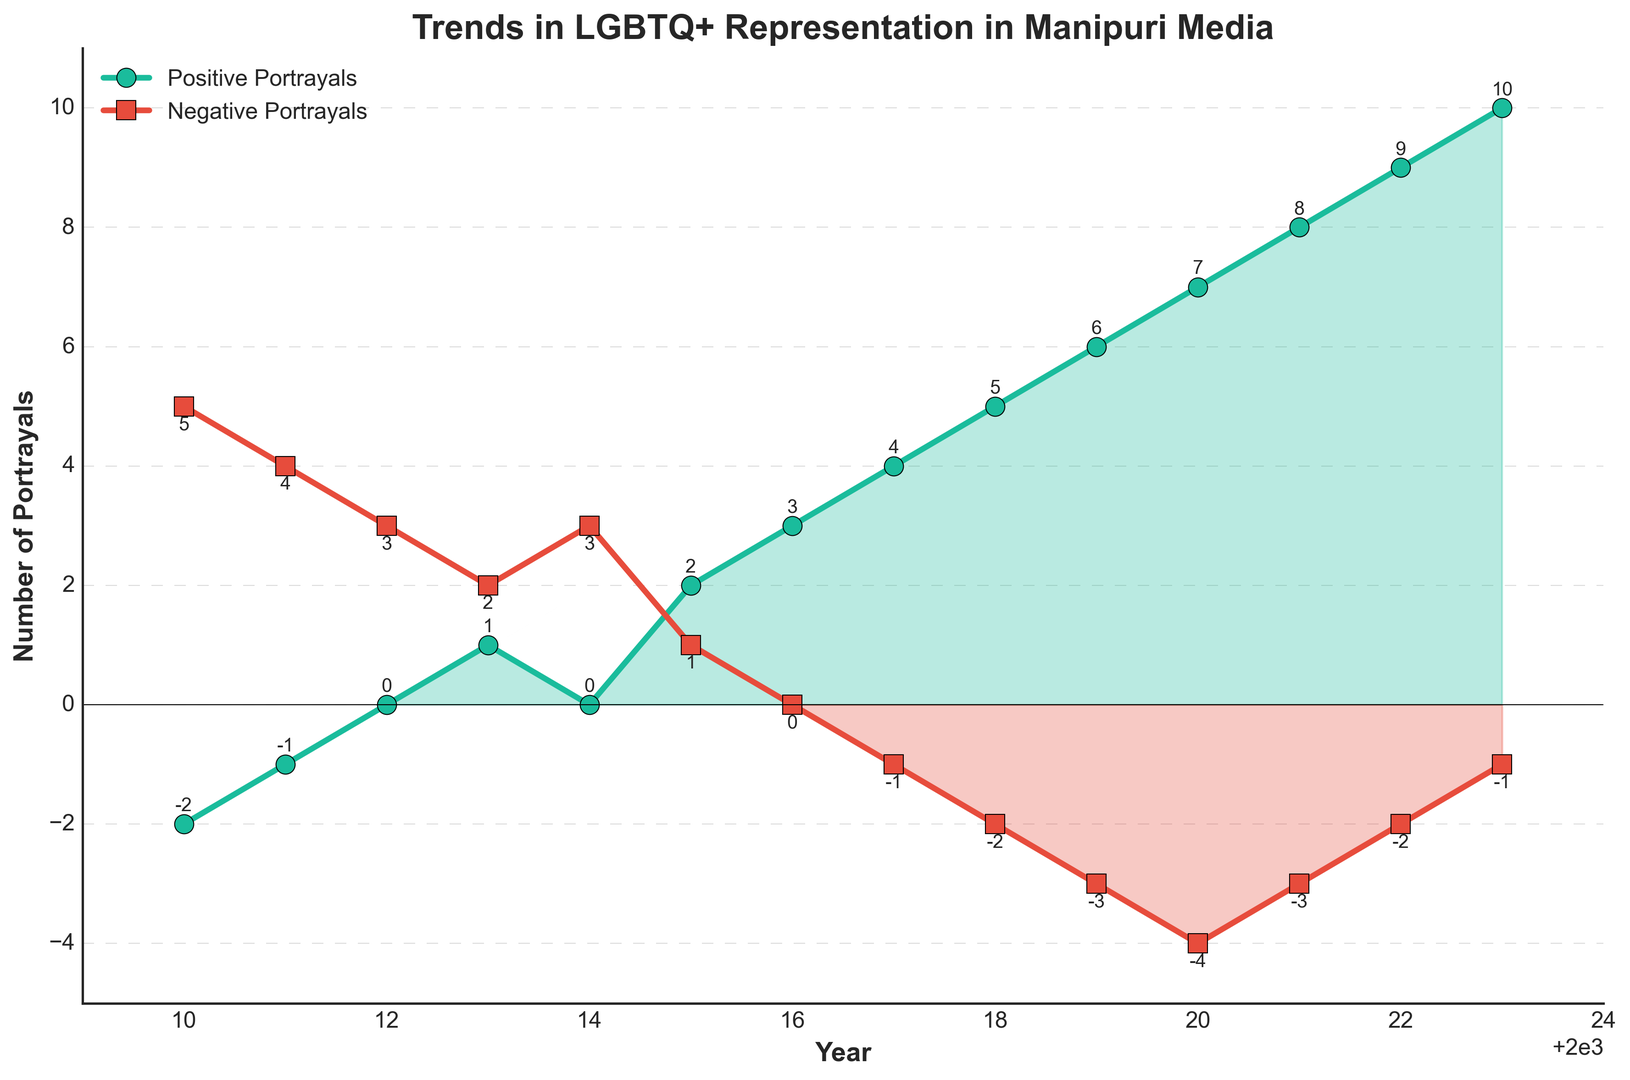What year did positive portrayals first exceed negative portrayals? In 2013, the positive portrayals (1) exceeded the negative portrayals (2 to 1) for the first time.
Answer: 2013 Which year had the highest number of positive portrayals? In 2023, the positive portrayals peaked at 10.
Answer: 2023 By how much did positive portrayals increase from 2010 to 2023? Positive portrayals in 2010 were -2, and in 2023 they were 10. The increase is 10 - (-2) = 12.
Answer: 12 Which year experienced the biggest drop in negative portrayals? The largest drop in negative portrayals occurred between 2010 (5) and 2016 (0), a reduction of 5 - 0 = 5.
Answer: 2016 When did negative portrayals fall below zero? Negative portrayals fell below zero for the first time in 2017 (-1).
Answer: 2017 Compare the positive portrayals between 2012 and 2015. By how much did they change? In 2012, positive portrayals were 0, and in 2015 they were 2, indicating an increase of 2 - 0 = 2.
Answer: 2 In which year did positive portrayals become equal to negative portrayals? In 2014, both positive and negative portrayals were equal, with both at 0.
Answer: 2014 What is the average number of negative portrayals from 2018 to 2023? The sums of negative portrayals from 2018 to 2023 are: -2, -3, -4, -3, -2, -1. The average is (-2 - 3 - 4 - 3 - 2 - 1) / 6 = -2.5.
Answer: -2.5 How many more positive portrayals were there in 2021 compared to 2018? Positive portrayals in 2021 were 8, while in 2018 they were 5, indicating an increase of 8 - 5 = 3.
Answer: 3 What is the difference between the negative portrayals in 2017 and 2020? In 2017, negative portrayals were -1, and in 2020 they were -4, showing a difference of -4 - (-1) = -3.
Answer: -3 